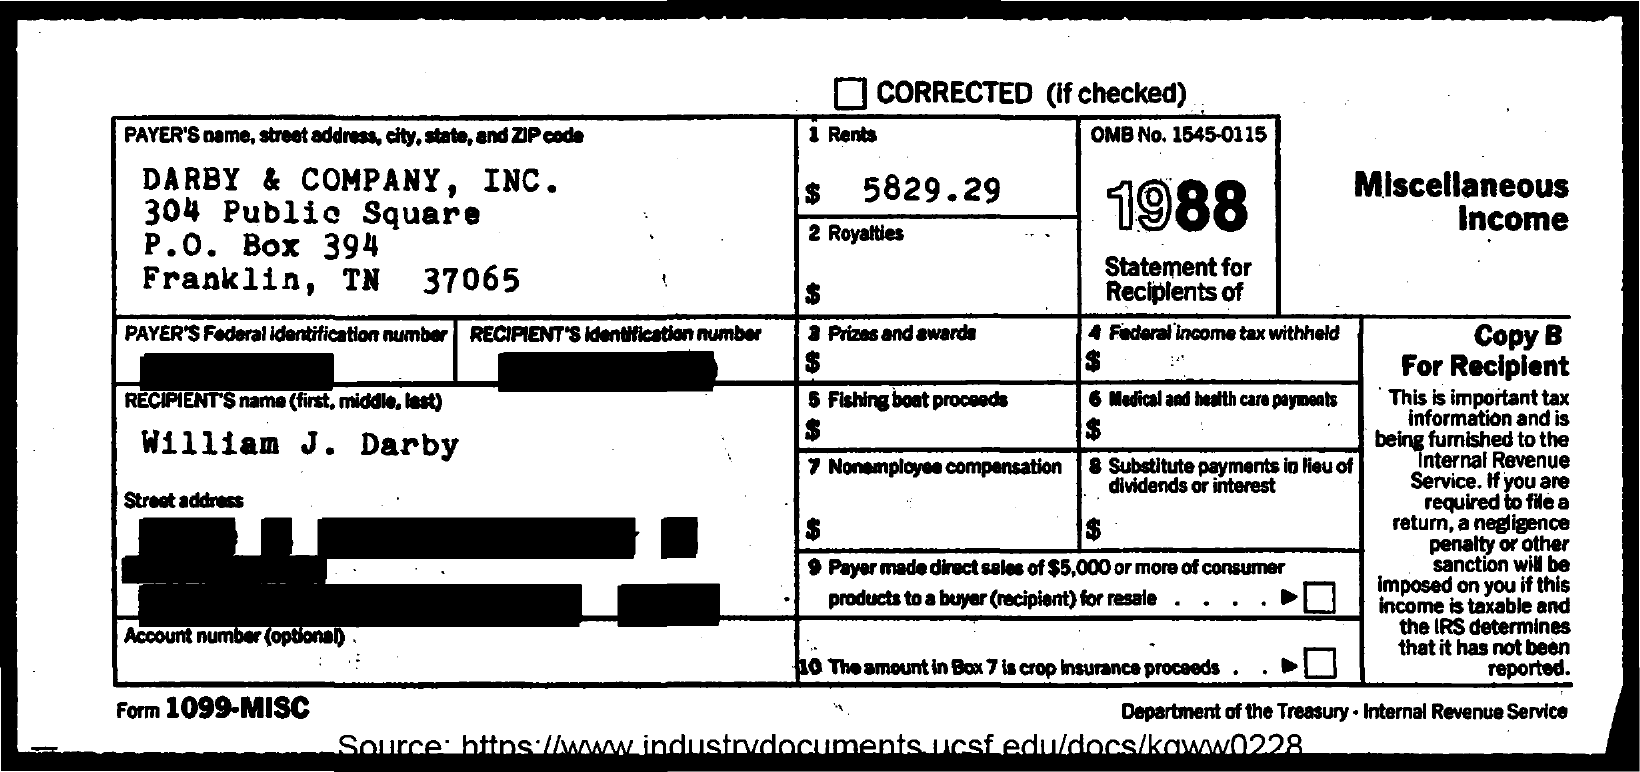What is the payer's name mentioned in the document?
Offer a terse response. DARBY & COMPANY, INC. What is the recipient's name given in the doument?
Provide a succinct answer. William J. Darby. What is the OMB No. mentioned in the document?
Offer a terse response. 1545-0115. 